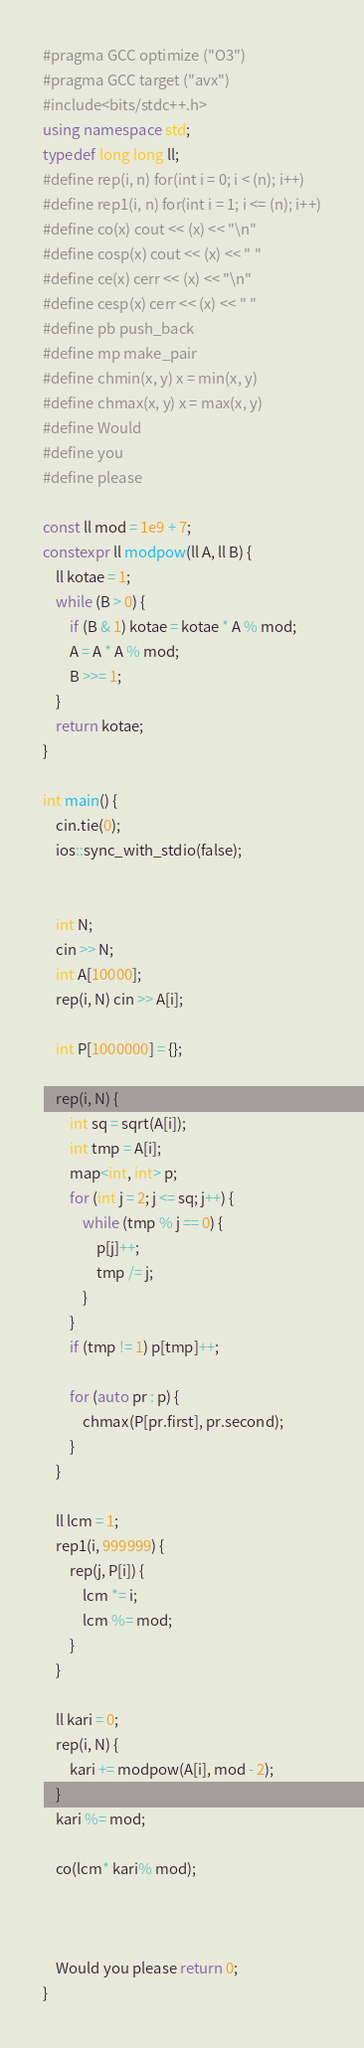Convert code to text. <code><loc_0><loc_0><loc_500><loc_500><_C++_>#pragma GCC optimize ("O3")
#pragma GCC target ("avx")
#include<bits/stdc++.h>
using namespace std;
typedef long long ll;
#define rep(i, n) for(int i = 0; i < (n); i++)
#define rep1(i, n) for(int i = 1; i <= (n); i++)
#define co(x) cout << (x) << "\n"
#define cosp(x) cout << (x) << " "
#define ce(x) cerr << (x) << "\n"
#define cesp(x) cerr << (x) << " "
#define pb push_back
#define mp make_pair
#define chmin(x, y) x = min(x, y)
#define chmax(x, y) x = max(x, y)
#define Would
#define you
#define please

const ll mod = 1e9 + 7;
constexpr ll modpow(ll A, ll B) {
	ll kotae = 1;
	while (B > 0) {
		if (B & 1) kotae = kotae * A % mod;
		A = A * A % mod;
		B >>= 1;
	}
	return kotae;
}

int main() {
	cin.tie(0);
	ios::sync_with_stdio(false);


	int N;
	cin >> N;
	int A[10000];
	rep(i, N) cin >> A[i];

	int P[1000000] = {};

	rep(i, N) {
		int sq = sqrt(A[i]);
		int tmp = A[i];
		map<int, int> p;
		for (int j = 2; j <= sq; j++) {
			while (tmp % j == 0) {
				p[j]++;
				tmp /= j;
			}
		}
		if (tmp != 1) p[tmp]++;

		for (auto pr : p) {
			chmax(P[pr.first], pr.second);
		}
	}

	ll lcm = 1;
	rep1(i, 999999) {
		rep(j, P[i]) {
			lcm *= i;
			lcm %= mod;
		}
	}

	ll kari = 0;
	rep(i, N) {
		kari += modpow(A[i], mod - 2);
	}
	kari %= mod;

	co(lcm* kari% mod);



	Would you please return 0;
}</code> 